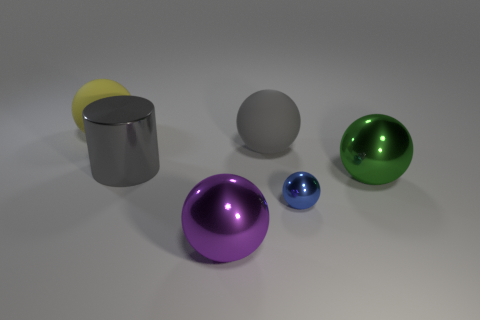Subtract 1 balls. How many balls are left? 4 Subtract all large gray rubber balls. How many balls are left? 4 Subtract all yellow balls. How many balls are left? 4 Subtract all cyan spheres. Subtract all purple cubes. How many spheres are left? 5 Add 2 tiny spheres. How many objects exist? 8 Subtract all balls. How many objects are left? 1 Add 6 large yellow objects. How many large yellow objects exist? 7 Subtract 0 yellow cylinders. How many objects are left? 6 Subtract all big yellow objects. Subtract all big gray shiny cylinders. How many objects are left? 4 Add 5 rubber balls. How many rubber balls are left? 7 